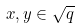Convert formula to latex. <formula><loc_0><loc_0><loc_500><loc_500>x , y \in \sqrt { q }</formula> 